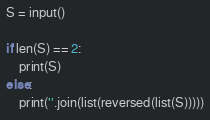<code> <loc_0><loc_0><loc_500><loc_500><_Python_>S = input()

if len(S) == 2:
    print(S)
else:
    print(''.join(list(reversed(list(S)))))
</code> 